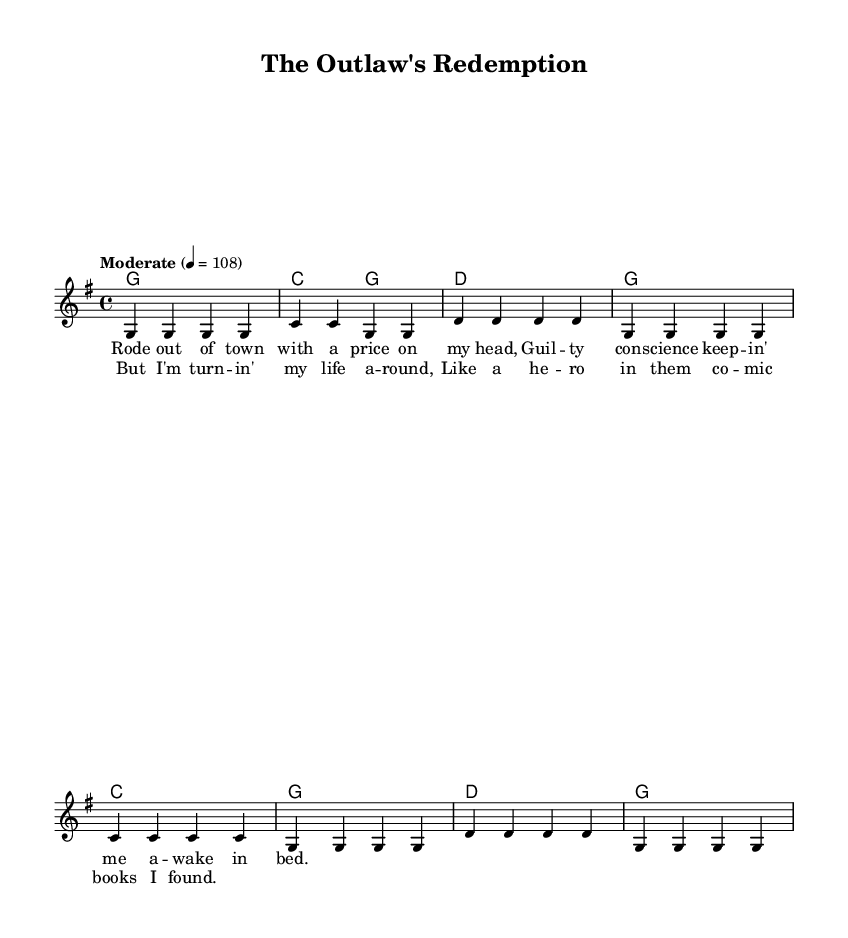What is the key signature of this music? The key signature is G major, which has one sharp (F#). We can identify this by looking at the key signature symbol at the beginning of the staff.
Answer: G major What is the time signature of this music? The time signature is 4/4, which indicates that there are four beats in each measure and a quarter note gets one beat. This is represented at the beginning of the staff, just after the key signature.
Answer: 4/4 What is the tempo marking of this piece? The tempo marking specifies "Moderate" at a speed of 108 beats per minute, which is indicated at the beginning of the score. This defines the pace at which the music should be played.
Answer: Moderate 4 = 108 What are the lyrics in the chorus? The chorus lyrics are "But I'm turn -- in' my life a -- round, Like a he -- ro in them co -- mic books I found." These lines are specified under the melody staff in the lyrics section, making it clear what should be sung during the chorus.
Answer: But I'm turn -- in' my life a -- round, Like a he -- ro in them co -- mic books I found How many measures are there in the verse? There are four measures in the verse section, each containing four beats as indicated by the 4/4 time signature. We can count the measures directly in the melody section of the score.
Answer: 4 What melodic structure is used in the chorus? The melodic structure of the chorus typically follows a repeated phrase pattern, with each melodic line consisting of four measures that align with the lyrics. This can be observed through the clustering of notes corresponding to the lyrics in the chorus.
Answer: Repeated phrase pattern In what way does this song parallel a hero's journey? The song's narrative of redemption and self-discovery, expressed through the lyrics "Like a he -- ro in them co -- mic books I found," illustrates themes common in the hero's journey, such as overcoming adversity and transformation. This can be analyzed by connecting the storyline in the lyrics to the archetypical progression of a hero's journey.
Answer: Redemption and self-discovery 